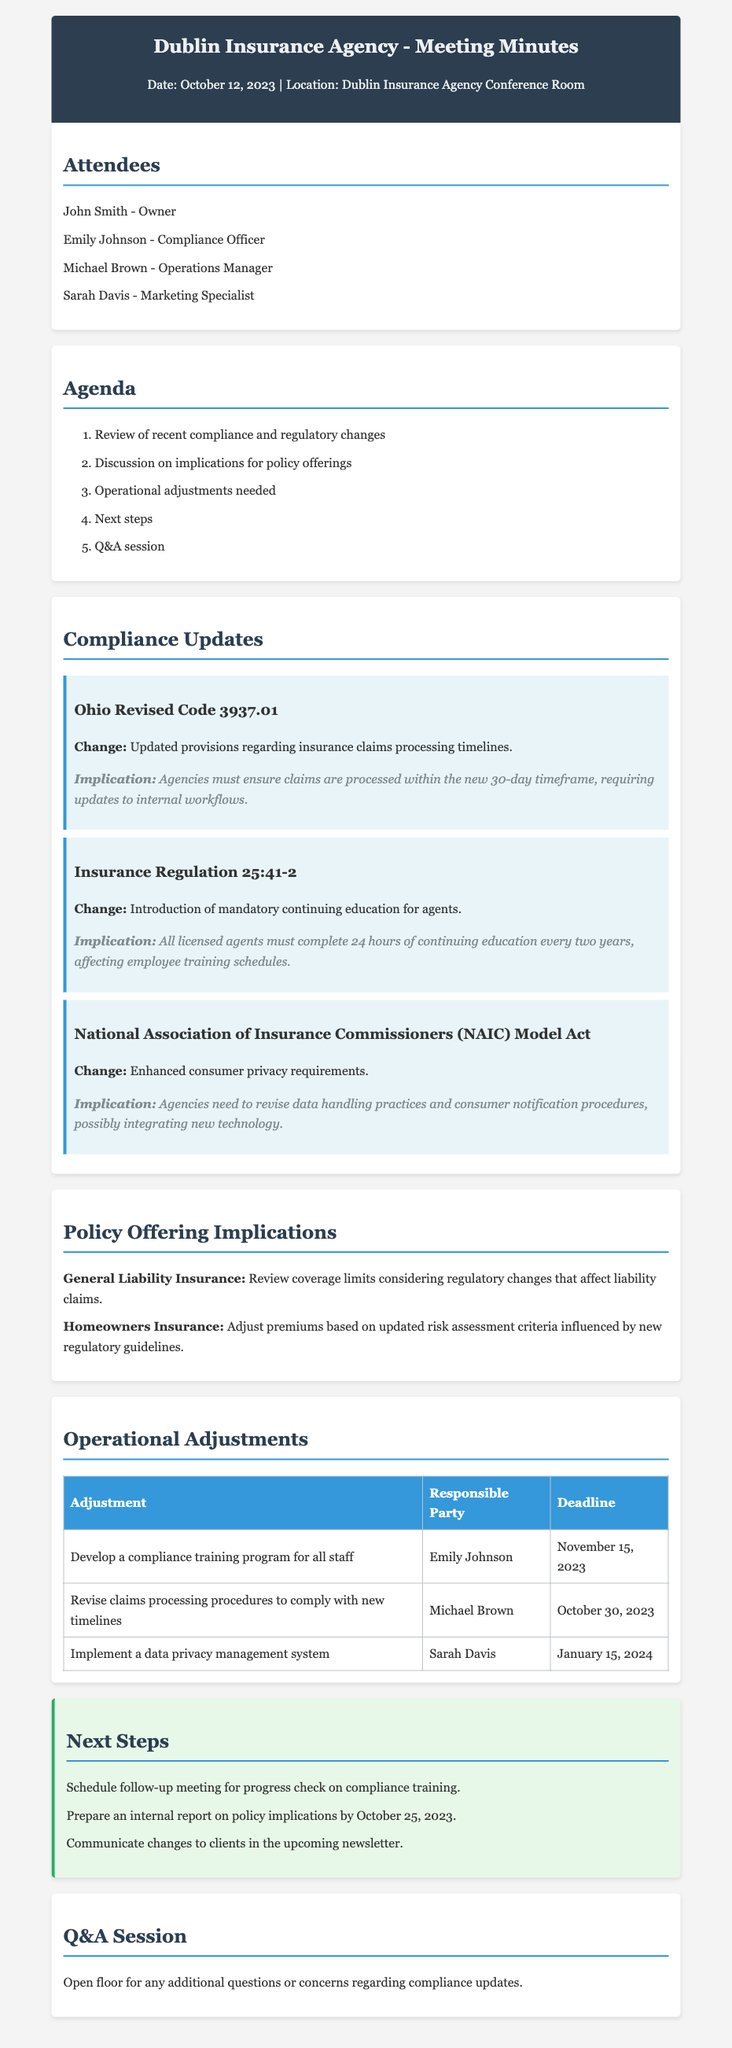What is the date of the meeting? The date of the meeting is stated in the header section of the document.
Answer: October 12, 2023 Who is responsible for developing a compliance training program? This information is found in the operational adjustments table, indicating who is assigned to each task.
Answer: Emily Johnson What is the deadline for revising claims processing procedures? The deadline is explicitly mentioned in the operational adjustments table.
Answer: October 30, 2023 What is the new claims processing timeline according to Ohio Revised Code 3937.01? This information is derived from the compliance updates section that describes the regulation changes.
Answer: 30-day timeframe How many hours of continuing education must agents complete every two years? The document specifies this requirement in the compliance updates section.
Answer: 24 hours What is one implication of the enhanced consumer privacy requirements? This is addressed in the implications of compliance updates regarding data handling practices.
Answer: Revise data handling practices What should the agency prepare by October 25, 2023? This is stated in the next steps section of the document.
Answer: An internal report on policy implications Who is responsible for implementing the data privacy management system? This detail is included in the operational adjustments table, which outlines responsibilities.
Answer: Sarah Davis 